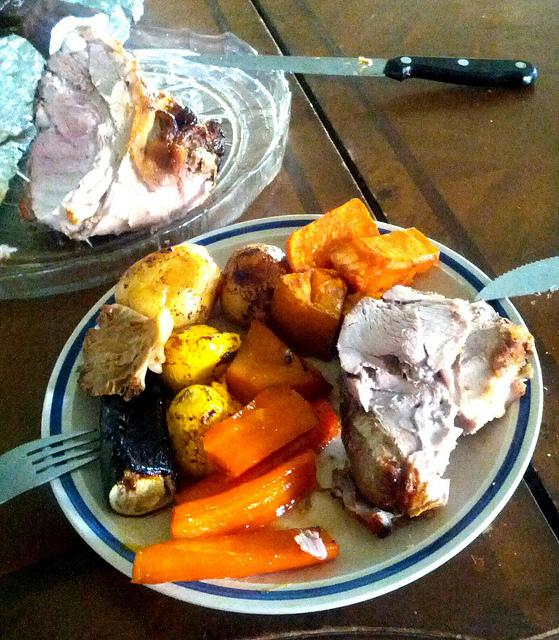How have these vegetables been cooked? grilled 